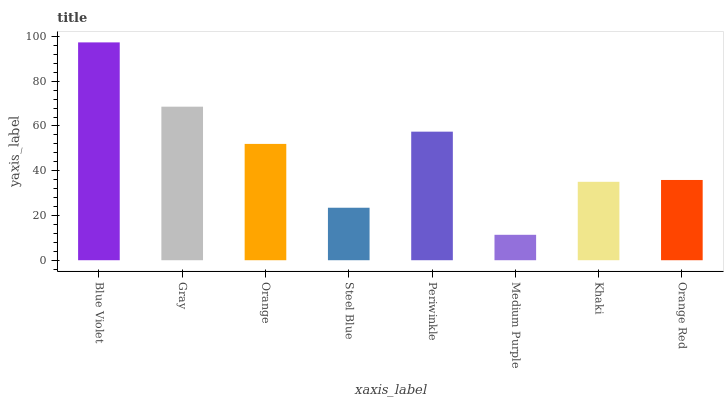Is Medium Purple the minimum?
Answer yes or no. Yes. Is Blue Violet the maximum?
Answer yes or no. Yes. Is Gray the minimum?
Answer yes or no. No. Is Gray the maximum?
Answer yes or no. No. Is Blue Violet greater than Gray?
Answer yes or no. Yes. Is Gray less than Blue Violet?
Answer yes or no. Yes. Is Gray greater than Blue Violet?
Answer yes or no. No. Is Blue Violet less than Gray?
Answer yes or no. No. Is Orange the high median?
Answer yes or no. Yes. Is Orange Red the low median?
Answer yes or no. Yes. Is Orange Red the high median?
Answer yes or no. No. Is Steel Blue the low median?
Answer yes or no. No. 